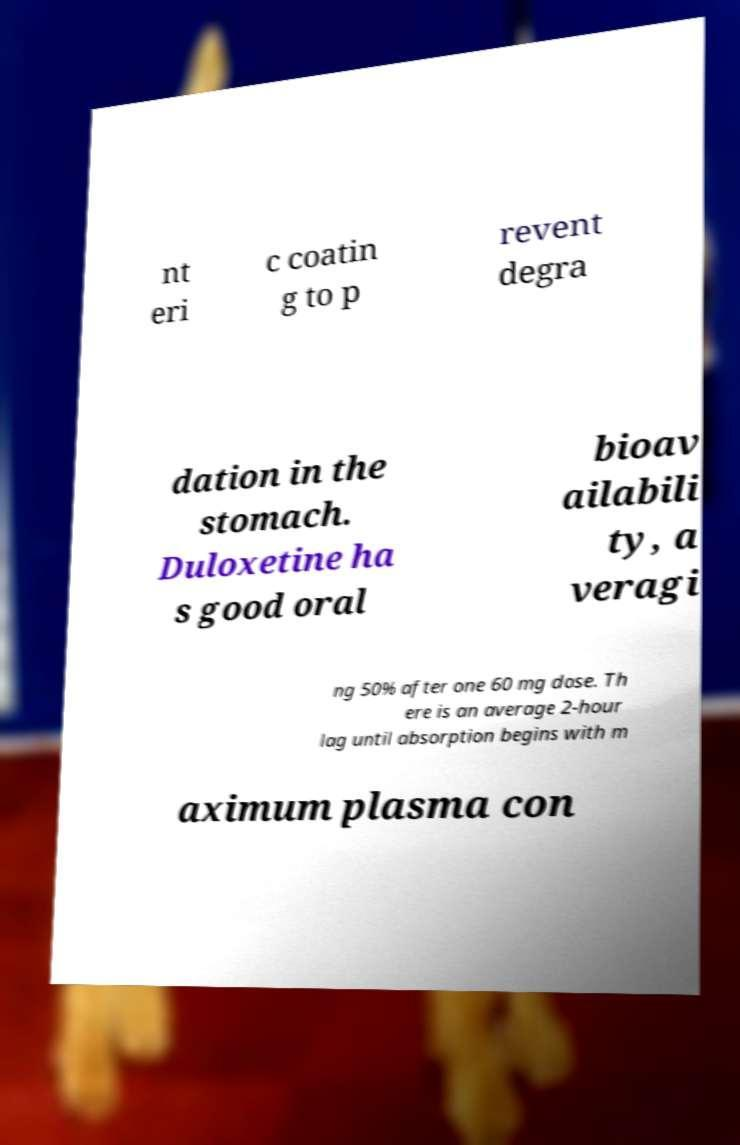Please identify and transcribe the text found in this image. nt eri c coatin g to p revent degra dation in the stomach. Duloxetine ha s good oral bioav ailabili ty, a veragi ng 50% after one 60 mg dose. Th ere is an average 2-hour lag until absorption begins with m aximum plasma con 